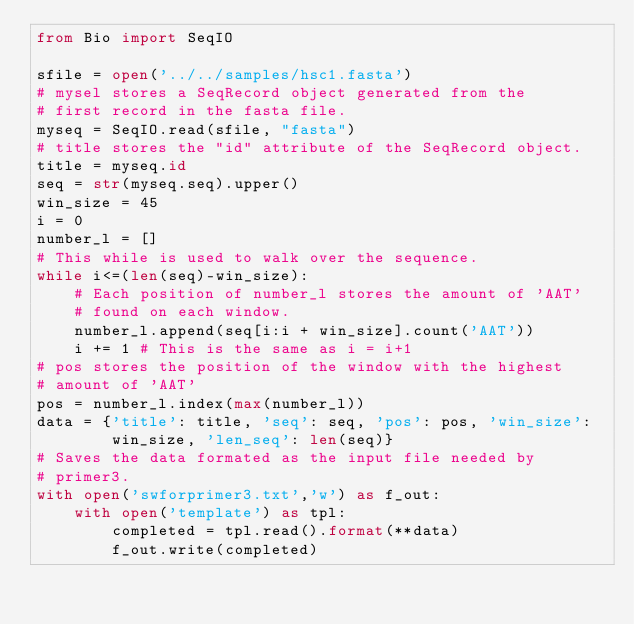<code> <loc_0><loc_0><loc_500><loc_500><_Python_>from Bio import SeqIO

sfile = open('../../samples/hsc1.fasta')
# mysel stores a SeqRecord object generated from the
# first record in the fasta file.
myseq = SeqIO.read(sfile, "fasta")
# title stores the "id" attribute of the SeqRecord object.
title = myseq.id
seq = str(myseq.seq).upper()
win_size = 45
i = 0
number_l = []
# This while is used to walk over the sequence.
while i<=(len(seq)-win_size):
    # Each position of number_l stores the amount of 'AAT'
    # found on each window.
    number_l.append(seq[i:i + win_size].count('AAT'))
    i += 1 # This is the same as i = i+1
# pos stores the position of the window with the highest
# amount of 'AAT'
pos = number_l.index(max(number_l))
data = {'title': title, 'seq': seq, 'pos': pos, 'win_size':
        win_size, 'len_seq': len(seq)}
# Saves the data formated as the input file needed by
# primer3.
with open('swforprimer3.txt','w') as f_out:
    with open('template') as tpl:
        completed = tpl.read().format(**data)
        f_out.write(completed)
</code> 